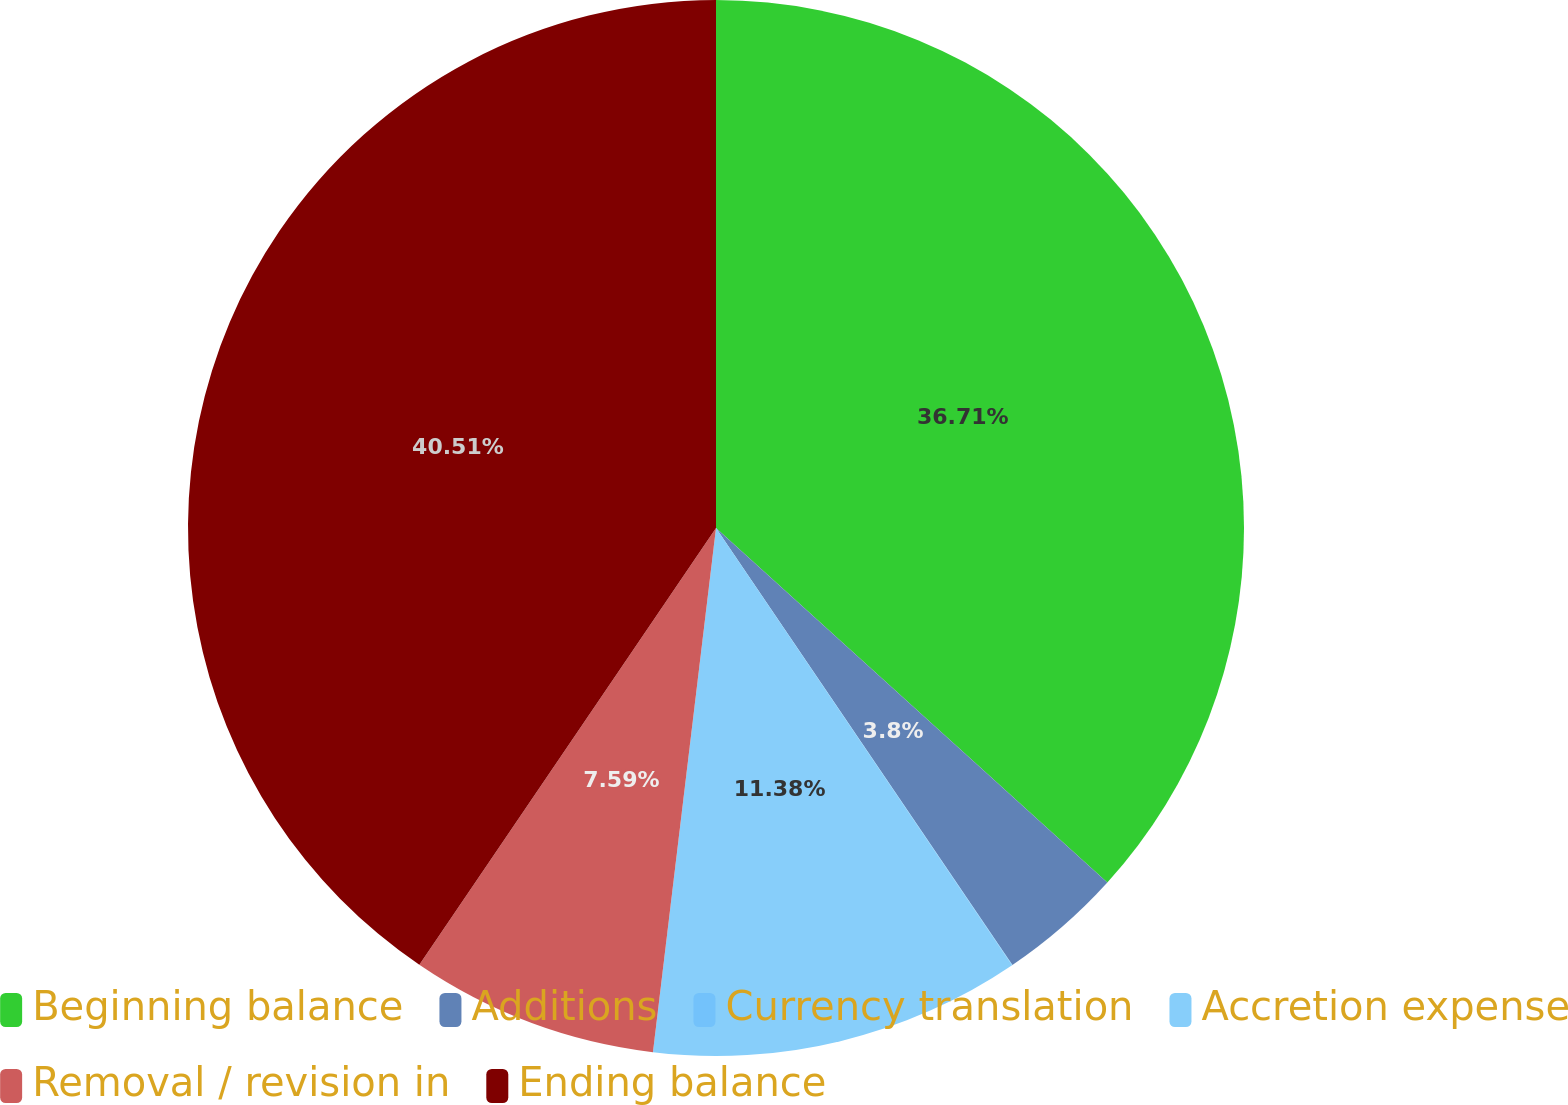Convert chart to OTSL. <chart><loc_0><loc_0><loc_500><loc_500><pie_chart><fcel>Beginning balance<fcel>Additions<fcel>Currency translation<fcel>Accretion expense<fcel>Removal / revision in<fcel>Ending balance<nl><fcel>36.71%<fcel>3.8%<fcel>0.01%<fcel>11.38%<fcel>7.59%<fcel>40.5%<nl></chart> 